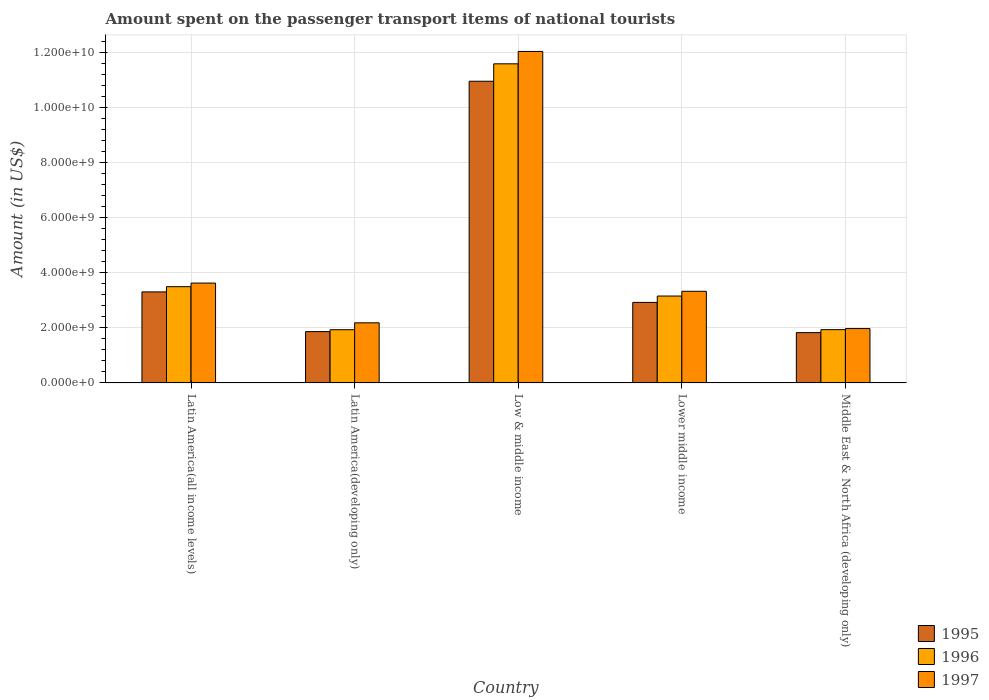How many groups of bars are there?
Your answer should be very brief. 5. Are the number of bars per tick equal to the number of legend labels?
Your response must be concise. Yes. How many bars are there on the 4th tick from the left?
Your answer should be very brief. 3. How many bars are there on the 2nd tick from the right?
Offer a terse response. 3. What is the label of the 1st group of bars from the left?
Give a very brief answer. Latin America(all income levels). In how many cases, is the number of bars for a given country not equal to the number of legend labels?
Give a very brief answer. 0. What is the amount spent on the passenger transport items of national tourists in 1995 in Middle East & North Africa (developing only)?
Provide a succinct answer. 1.83e+09. Across all countries, what is the maximum amount spent on the passenger transport items of national tourists in 1995?
Provide a succinct answer. 1.10e+1. Across all countries, what is the minimum amount spent on the passenger transport items of national tourists in 1997?
Give a very brief answer. 1.97e+09. In which country was the amount spent on the passenger transport items of national tourists in 1997 maximum?
Ensure brevity in your answer.  Low & middle income. In which country was the amount spent on the passenger transport items of national tourists in 1996 minimum?
Your answer should be compact. Latin America(developing only). What is the total amount spent on the passenger transport items of national tourists in 1997 in the graph?
Offer a very short reply. 2.31e+1. What is the difference between the amount spent on the passenger transport items of national tourists in 1995 in Lower middle income and that in Middle East & North Africa (developing only)?
Offer a very short reply. 1.10e+09. What is the difference between the amount spent on the passenger transport items of national tourists in 1995 in Latin America(all income levels) and the amount spent on the passenger transport items of national tourists in 1997 in Middle East & North Africa (developing only)?
Give a very brief answer. 1.33e+09. What is the average amount spent on the passenger transport items of national tourists in 1995 per country?
Offer a very short reply. 4.18e+09. What is the difference between the amount spent on the passenger transport items of national tourists of/in 1995 and amount spent on the passenger transport items of national tourists of/in 1996 in Middle East & North Africa (developing only)?
Provide a succinct answer. -1.08e+08. What is the ratio of the amount spent on the passenger transport items of national tourists in 1995 in Latin America(developing only) to that in Lower middle income?
Ensure brevity in your answer.  0.64. What is the difference between the highest and the second highest amount spent on the passenger transport items of national tourists in 1995?
Your answer should be very brief. -7.65e+09. What is the difference between the highest and the lowest amount spent on the passenger transport items of national tourists in 1997?
Offer a very short reply. 1.01e+1. In how many countries, is the amount spent on the passenger transport items of national tourists in 1995 greater than the average amount spent on the passenger transport items of national tourists in 1995 taken over all countries?
Give a very brief answer. 1. Is the sum of the amount spent on the passenger transport items of national tourists in 1997 in Low & middle income and Middle East & North Africa (developing only) greater than the maximum amount spent on the passenger transport items of national tourists in 1995 across all countries?
Provide a short and direct response. Yes. What does the 2nd bar from the left in Middle East & North Africa (developing only) represents?
Provide a short and direct response. 1996. What does the 3rd bar from the right in Middle East & North Africa (developing only) represents?
Provide a succinct answer. 1995. How many bars are there?
Give a very brief answer. 15. Are all the bars in the graph horizontal?
Offer a very short reply. No. How many countries are there in the graph?
Offer a very short reply. 5. Are the values on the major ticks of Y-axis written in scientific E-notation?
Your answer should be compact. Yes. Does the graph contain any zero values?
Your response must be concise. No. How many legend labels are there?
Provide a short and direct response. 3. How are the legend labels stacked?
Give a very brief answer. Vertical. What is the title of the graph?
Your answer should be compact. Amount spent on the passenger transport items of national tourists. Does "2012" appear as one of the legend labels in the graph?
Your answer should be compact. No. What is the label or title of the X-axis?
Your answer should be compact. Country. What is the Amount (in US$) in 1995 in Latin America(all income levels)?
Give a very brief answer. 3.31e+09. What is the Amount (in US$) in 1996 in Latin America(all income levels)?
Offer a very short reply. 3.50e+09. What is the Amount (in US$) in 1997 in Latin America(all income levels)?
Your response must be concise. 3.63e+09. What is the Amount (in US$) in 1995 in Latin America(developing only)?
Offer a very short reply. 1.86e+09. What is the Amount (in US$) in 1996 in Latin America(developing only)?
Your response must be concise. 1.93e+09. What is the Amount (in US$) in 1997 in Latin America(developing only)?
Provide a short and direct response. 2.18e+09. What is the Amount (in US$) of 1995 in Low & middle income?
Your response must be concise. 1.10e+1. What is the Amount (in US$) of 1996 in Low & middle income?
Offer a very short reply. 1.16e+1. What is the Amount (in US$) in 1997 in Low & middle income?
Offer a terse response. 1.20e+1. What is the Amount (in US$) of 1995 in Lower middle income?
Your answer should be compact. 2.92e+09. What is the Amount (in US$) of 1996 in Lower middle income?
Your response must be concise. 3.16e+09. What is the Amount (in US$) in 1997 in Lower middle income?
Your answer should be very brief. 3.33e+09. What is the Amount (in US$) of 1995 in Middle East & North Africa (developing only)?
Your answer should be compact. 1.83e+09. What is the Amount (in US$) in 1996 in Middle East & North Africa (developing only)?
Make the answer very short. 1.94e+09. What is the Amount (in US$) of 1997 in Middle East & North Africa (developing only)?
Your answer should be very brief. 1.97e+09. Across all countries, what is the maximum Amount (in US$) of 1995?
Provide a succinct answer. 1.10e+1. Across all countries, what is the maximum Amount (in US$) of 1996?
Provide a succinct answer. 1.16e+1. Across all countries, what is the maximum Amount (in US$) of 1997?
Your response must be concise. 1.20e+1. Across all countries, what is the minimum Amount (in US$) in 1995?
Provide a succinct answer. 1.83e+09. Across all countries, what is the minimum Amount (in US$) in 1996?
Your response must be concise. 1.93e+09. Across all countries, what is the minimum Amount (in US$) of 1997?
Provide a succinct answer. 1.97e+09. What is the total Amount (in US$) of 1995 in the graph?
Offer a very short reply. 2.09e+1. What is the total Amount (in US$) in 1996 in the graph?
Keep it short and to the point. 2.21e+1. What is the total Amount (in US$) in 1997 in the graph?
Your answer should be compact. 2.31e+1. What is the difference between the Amount (in US$) in 1995 in Latin America(all income levels) and that in Latin America(developing only)?
Ensure brevity in your answer.  1.44e+09. What is the difference between the Amount (in US$) in 1996 in Latin America(all income levels) and that in Latin America(developing only)?
Ensure brevity in your answer.  1.56e+09. What is the difference between the Amount (in US$) in 1997 in Latin America(all income levels) and that in Latin America(developing only)?
Offer a terse response. 1.44e+09. What is the difference between the Amount (in US$) in 1995 in Latin America(all income levels) and that in Low & middle income?
Your answer should be compact. -7.65e+09. What is the difference between the Amount (in US$) in 1996 in Latin America(all income levels) and that in Low & middle income?
Offer a very short reply. -8.09e+09. What is the difference between the Amount (in US$) of 1997 in Latin America(all income levels) and that in Low & middle income?
Your answer should be compact. -8.41e+09. What is the difference between the Amount (in US$) in 1995 in Latin America(all income levels) and that in Lower middle income?
Provide a succinct answer. 3.81e+08. What is the difference between the Amount (in US$) of 1996 in Latin America(all income levels) and that in Lower middle income?
Offer a very short reply. 3.40e+08. What is the difference between the Amount (in US$) in 1997 in Latin America(all income levels) and that in Lower middle income?
Make the answer very short. 2.98e+08. What is the difference between the Amount (in US$) in 1995 in Latin America(all income levels) and that in Middle East & North Africa (developing only)?
Your answer should be very brief. 1.48e+09. What is the difference between the Amount (in US$) of 1996 in Latin America(all income levels) and that in Middle East & North Africa (developing only)?
Your answer should be compact. 1.56e+09. What is the difference between the Amount (in US$) of 1997 in Latin America(all income levels) and that in Middle East & North Africa (developing only)?
Keep it short and to the point. 1.65e+09. What is the difference between the Amount (in US$) in 1995 in Latin America(developing only) and that in Low & middle income?
Your answer should be compact. -9.09e+09. What is the difference between the Amount (in US$) in 1996 in Latin America(developing only) and that in Low & middle income?
Offer a very short reply. -9.65e+09. What is the difference between the Amount (in US$) in 1997 in Latin America(developing only) and that in Low & middle income?
Your response must be concise. -9.85e+09. What is the difference between the Amount (in US$) in 1995 in Latin America(developing only) and that in Lower middle income?
Your answer should be compact. -1.06e+09. What is the difference between the Amount (in US$) of 1996 in Latin America(developing only) and that in Lower middle income?
Your answer should be very brief. -1.22e+09. What is the difference between the Amount (in US$) of 1997 in Latin America(developing only) and that in Lower middle income?
Provide a succinct answer. -1.15e+09. What is the difference between the Amount (in US$) of 1995 in Latin America(developing only) and that in Middle East & North Africa (developing only)?
Ensure brevity in your answer.  3.68e+07. What is the difference between the Amount (in US$) in 1996 in Latin America(developing only) and that in Middle East & North Africa (developing only)?
Offer a terse response. -2.54e+06. What is the difference between the Amount (in US$) of 1997 in Latin America(developing only) and that in Middle East & North Africa (developing only)?
Offer a very short reply. 2.09e+08. What is the difference between the Amount (in US$) of 1995 in Low & middle income and that in Lower middle income?
Your answer should be compact. 8.03e+09. What is the difference between the Amount (in US$) of 1996 in Low & middle income and that in Lower middle income?
Provide a short and direct response. 8.43e+09. What is the difference between the Amount (in US$) of 1997 in Low & middle income and that in Lower middle income?
Offer a very short reply. 8.71e+09. What is the difference between the Amount (in US$) of 1995 in Low & middle income and that in Middle East & North Africa (developing only)?
Offer a terse response. 9.13e+09. What is the difference between the Amount (in US$) of 1996 in Low & middle income and that in Middle East & North Africa (developing only)?
Keep it short and to the point. 9.65e+09. What is the difference between the Amount (in US$) in 1997 in Low & middle income and that in Middle East & North Africa (developing only)?
Provide a succinct answer. 1.01e+1. What is the difference between the Amount (in US$) of 1995 in Lower middle income and that in Middle East & North Africa (developing only)?
Make the answer very short. 1.10e+09. What is the difference between the Amount (in US$) of 1996 in Lower middle income and that in Middle East & North Africa (developing only)?
Give a very brief answer. 1.22e+09. What is the difference between the Amount (in US$) of 1997 in Lower middle income and that in Middle East & North Africa (developing only)?
Provide a short and direct response. 1.35e+09. What is the difference between the Amount (in US$) in 1995 in Latin America(all income levels) and the Amount (in US$) in 1996 in Latin America(developing only)?
Offer a terse response. 1.37e+09. What is the difference between the Amount (in US$) in 1995 in Latin America(all income levels) and the Amount (in US$) in 1997 in Latin America(developing only)?
Offer a terse response. 1.12e+09. What is the difference between the Amount (in US$) of 1996 in Latin America(all income levels) and the Amount (in US$) of 1997 in Latin America(developing only)?
Your answer should be very brief. 1.31e+09. What is the difference between the Amount (in US$) in 1995 in Latin America(all income levels) and the Amount (in US$) in 1996 in Low & middle income?
Offer a very short reply. -8.28e+09. What is the difference between the Amount (in US$) of 1995 in Latin America(all income levels) and the Amount (in US$) of 1997 in Low & middle income?
Ensure brevity in your answer.  -8.73e+09. What is the difference between the Amount (in US$) of 1996 in Latin America(all income levels) and the Amount (in US$) of 1997 in Low & middle income?
Keep it short and to the point. -8.54e+09. What is the difference between the Amount (in US$) in 1995 in Latin America(all income levels) and the Amount (in US$) in 1996 in Lower middle income?
Provide a succinct answer. 1.50e+08. What is the difference between the Amount (in US$) of 1995 in Latin America(all income levels) and the Amount (in US$) of 1997 in Lower middle income?
Keep it short and to the point. -2.21e+07. What is the difference between the Amount (in US$) in 1996 in Latin America(all income levels) and the Amount (in US$) in 1997 in Lower middle income?
Offer a terse response. 1.67e+08. What is the difference between the Amount (in US$) in 1995 in Latin America(all income levels) and the Amount (in US$) in 1996 in Middle East & North Africa (developing only)?
Your response must be concise. 1.37e+09. What is the difference between the Amount (in US$) of 1995 in Latin America(all income levels) and the Amount (in US$) of 1997 in Middle East & North Africa (developing only)?
Your response must be concise. 1.33e+09. What is the difference between the Amount (in US$) of 1996 in Latin America(all income levels) and the Amount (in US$) of 1997 in Middle East & North Africa (developing only)?
Offer a terse response. 1.52e+09. What is the difference between the Amount (in US$) of 1995 in Latin America(developing only) and the Amount (in US$) of 1996 in Low & middle income?
Your response must be concise. -9.72e+09. What is the difference between the Amount (in US$) of 1995 in Latin America(developing only) and the Amount (in US$) of 1997 in Low & middle income?
Provide a succinct answer. -1.02e+1. What is the difference between the Amount (in US$) of 1996 in Latin America(developing only) and the Amount (in US$) of 1997 in Low & middle income?
Offer a terse response. -1.01e+1. What is the difference between the Amount (in US$) in 1995 in Latin America(developing only) and the Amount (in US$) in 1996 in Lower middle income?
Make the answer very short. -1.29e+09. What is the difference between the Amount (in US$) of 1995 in Latin America(developing only) and the Amount (in US$) of 1997 in Lower middle income?
Your response must be concise. -1.46e+09. What is the difference between the Amount (in US$) in 1996 in Latin America(developing only) and the Amount (in US$) in 1997 in Lower middle income?
Make the answer very short. -1.40e+09. What is the difference between the Amount (in US$) of 1995 in Latin America(developing only) and the Amount (in US$) of 1996 in Middle East & North Africa (developing only)?
Offer a terse response. -7.09e+07. What is the difference between the Amount (in US$) in 1995 in Latin America(developing only) and the Amount (in US$) in 1997 in Middle East & North Africa (developing only)?
Offer a very short reply. -1.10e+08. What is the difference between the Amount (in US$) in 1996 in Latin America(developing only) and the Amount (in US$) in 1997 in Middle East & North Africa (developing only)?
Give a very brief answer. -4.17e+07. What is the difference between the Amount (in US$) of 1995 in Low & middle income and the Amount (in US$) of 1996 in Lower middle income?
Offer a very short reply. 7.80e+09. What is the difference between the Amount (in US$) of 1995 in Low & middle income and the Amount (in US$) of 1997 in Lower middle income?
Offer a very short reply. 7.63e+09. What is the difference between the Amount (in US$) of 1996 in Low & middle income and the Amount (in US$) of 1997 in Lower middle income?
Make the answer very short. 8.26e+09. What is the difference between the Amount (in US$) of 1995 in Low & middle income and the Amount (in US$) of 1996 in Middle East & North Africa (developing only)?
Your answer should be very brief. 9.02e+09. What is the difference between the Amount (in US$) of 1995 in Low & middle income and the Amount (in US$) of 1997 in Middle East & North Africa (developing only)?
Offer a very short reply. 8.98e+09. What is the difference between the Amount (in US$) in 1996 in Low & middle income and the Amount (in US$) in 1997 in Middle East & North Africa (developing only)?
Ensure brevity in your answer.  9.61e+09. What is the difference between the Amount (in US$) of 1995 in Lower middle income and the Amount (in US$) of 1996 in Middle East & North Africa (developing only)?
Offer a terse response. 9.90e+08. What is the difference between the Amount (in US$) of 1995 in Lower middle income and the Amount (in US$) of 1997 in Middle East & North Africa (developing only)?
Provide a succinct answer. 9.50e+08. What is the difference between the Amount (in US$) of 1996 in Lower middle income and the Amount (in US$) of 1997 in Middle East & North Africa (developing only)?
Offer a very short reply. 1.18e+09. What is the average Amount (in US$) in 1995 per country?
Ensure brevity in your answer.  4.18e+09. What is the average Amount (in US$) of 1996 per country?
Provide a short and direct response. 4.42e+09. What is the average Amount (in US$) of 1997 per country?
Ensure brevity in your answer.  4.63e+09. What is the difference between the Amount (in US$) in 1995 and Amount (in US$) in 1996 in Latin America(all income levels)?
Keep it short and to the point. -1.89e+08. What is the difference between the Amount (in US$) of 1995 and Amount (in US$) of 1997 in Latin America(all income levels)?
Provide a succinct answer. -3.20e+08. What is the difference between the Amount (in US$) in 1996 and Amount (in US$) in 1997 in Latin America(all income levels)?
Offer a very short reply. -1.31e+08. What is the difference between the Amount (in US$) in 1995 and Amount (in US$) in 1996 in Latin America(developing only)?
Ensure brevity in your answer.  -6.84e+07. What is the difference between the Amount (in US$) in 1995 and Amount (in US$) in 1997 in Latin America(developing only)?
Give a very brief answer. -3.19e+08. What is the difference between the Amount (in US$) of 1996 and Amount (in US$) of 1997 in Latin America(developing only)?
Provide a short and direct response. -2.50e+08. What is the difference between the Amount (in US$) in 1995 and Amount (in US$) in 1996 in Low & middle income?
Your answer should be compact. -6.33e+08. What is the difference between the Amount (in US$) of 1995 and Amount (in US$) of 1997 in Low & middle income?
Offer a very short reply. -1.08e+09. What is the difference between the Amount (in US$) in 1996 and Amount (in US$) in 1997 in Low & middle income?
Provide a short and direct response. -4.49e+08. What is the difference between the Amount (in US$) in 1995 and Amount (in US$) in 1996 in Lower middle income?
Keep it short and to the point. -2.31e+08. What is the difference between the Amount (in US$) of 1995 and Amount (in US$) of 1997 in Lower middle income?
Give a very brief answer. -4.03e+08. What is the difference between the Amount (in US$) in 1996 and Amount (in US$) in 1997 in Lower middle income?
Keep it short and to the point. -1.73e+08. What is the difference between the Amount (in US$) of 1995 and Amount (in US$) of 1996 in Middle East & North Africa (developing only)?
Your response must be concise. -1.08e+08. What is the difference between the Amount (in US$) of 1995 and Amount (in US$) of 1997 in Middle East & North Africa (developing only)?
Ensure brevity in your answer.  -1.47e+08. What is the difference between the Amount (in US$) of 1996 and Amount (in US$) of 1997 in Middle East & North Africa (developing only)?
Ensure brevity in your answer.  -3.92e+07. What is the ratio of the Amount (in US$) in 1995 in Latin America(all income levels) to that in Latin America(developing only)?
Provide a succinct answer. 1.77. What is the ratio of the Amount (in US$) in 1996 in Latin America(all income levels) to that in Latin America(developing only)?
Give a very brief answer. 1.81. What is the ratio of the Amount (in US$) of 1997 in Latin America(all income levels) to that in Latin America(developing only)?
Your answer should be very brief. 1.66. What is the ratio of the Amount (in US$) of 1995 in Latin America(all income levels) to that in Low & middle income?
Make the answer very short. 0.3. What is the ratio of the Amount (in US$) of 1996 in Latin America(all income levels) to that in Low & middle income?
Your answer should be compact. 0.3. What is the ratio of the Amount (in US$) of 1997 in Latin America(all income levels) to that in Low & middle income?
Offer a very short reply. 0.3. What is the ratio of the Amount (in US$) in 1995 in Latin America(all income levels) to that in Lower middle income?
Your answer should be very brief. 1.13. What is the ratio of the Amount (in US$) in 1996 in Latin America(all income levels) to that in Lower middle income?
Offer a terse response. 1.11. What is the ratio of the Amount (in US$) of 1997 in Latin America(all income levels) to that in Lower middle income?
Keep it short and to the point. 1.09. What is the ratio of the Amount (in US$) of 1995 in Latin America(all income levels) to that in Middle East & North Africa (developing only)?
Keep it short and to the point. 1.81. What is the ratio of the Amount (in US$) in 1996 in Latin America(all income levels) to that in Middle East & North Africa (developing only)?
Keep it short and to the point. 1.81. What is the ratio of the Amount (in US$) of 1997 in Latin America(all income levels) to that in Middle East & North Africa (developing only)?
Offer a very short reply. 1.84. What is the ratio of the Amount (in US$) in 1995 in Latin America(developing only) to that in Low & middle income?
Give a very brief answer. 0.17. What is the ratio of the Amount (in US$) in 1996 in Latin America(developing only) to that in Low & middle income?
Offer a very short reply. 0.17. What is the ratio of the Amount (in US$) in 1997 in Latin America(developing only) to that in Low & middle income?
Offer a very short reply. 0.18. What is the ratio of the Amount (in US$) of 1995 in Latin America(developing only) to that in Lower middle income?
Give a very brief answer. 0.64. What is the ratio of the Amount (in US$) of 1996 in Latin America(developing only) to that in Lower middle income?
Provide a succinct answer. 0.61. What is the ratio of the Amount (in US$) of 1997 in Latin America(developing only) to that in Lower middle income?
Ensure brevity in your answer.  0.66. What is the ratio of the Amount (in US$) in 1995 in Latin America(developing only) to that in Middle East & North Africa (developing only)?
Keep it short and to the point. 1.02. What is the ratio of the Amount (in US$) of 1996 in Latin America(developing only) to that in Middle East & North Africa (developing only)?
Ensure brevity in your answer.  1. What is the ratio of the Amount (in US$) of 1997 in Latin America(developing only) to that in Middle East & North Africa (developing only)?
Make the answer very short. 1.11. What is the ratio of the Amount (in US$) in 1995 in Low & middle income to that in Lower middle income?
Keep it short and to the point. 3.75. What is the ratio of the Amount (in US$) of 1996 in Low & middle income to that in Lower middle income?
Provide a short and direct response. 3.67. What is the ratio of the Amount (in US$) in 1997 in Low & middle income to that in Lower middle income?
Offer a very short reply. 3.62. What is the ratio of the Amount (in US$) in 1995 in Low & middle income to that in Middle East & North Africa (developing only)?
Your answer should be compact. 5.99. What is the ratio of the Amount (in US$) in 1996 in Low & middle income to that in Middle East & North Africa (developing only)?
Provide a short and direct response. 5.99. What is the ratio of the Amount (in US$) in 1997 in Low & middle income to that in Middle East & North Africa (developing only)?
Your answer should be very brief. 6.1. What is the ratio of the Amount (in US$) of 1995 in Lower middle income to that in Middle East & North Africa (developing only)?
Your answer should be compact. 1.6. What is the ratio of the Amount (in US$) in 1996 in Lower middle income to that in Middle East & North Africa (developing only)?
Keep it short and to the point. 1.63. What is the ratio of the Amount (in US$) in 1997 in Lower middle income to that in Middle East & North Africa (developing only)?
Make the answer very short. 1.69. What is the difference between the highest and the second highest Amount (in US$) of 1995?
Make the answer very short. 7.65e+09. What is the difference between the highest and the second highest Amount (in US$) in 1996?
Make the answer very short. 8.09e+09. What is the difference between the highest and the second highest Amount (in US$) in 1997?
Your answer should be compact. 8.41e+09. What is the difference between the highest and the lowest Amount (in US$) in 1995?
Your response must be concise. 9.13e+09. What is the difference between the highest and the lowest Amount (in US$) in 1996?
Provide a succinct answer. 9.65e+09. What is the difference between the highest and the lowest Amount (in US$) in 1997?
Keep it short and to the point. 1.01e+1. 